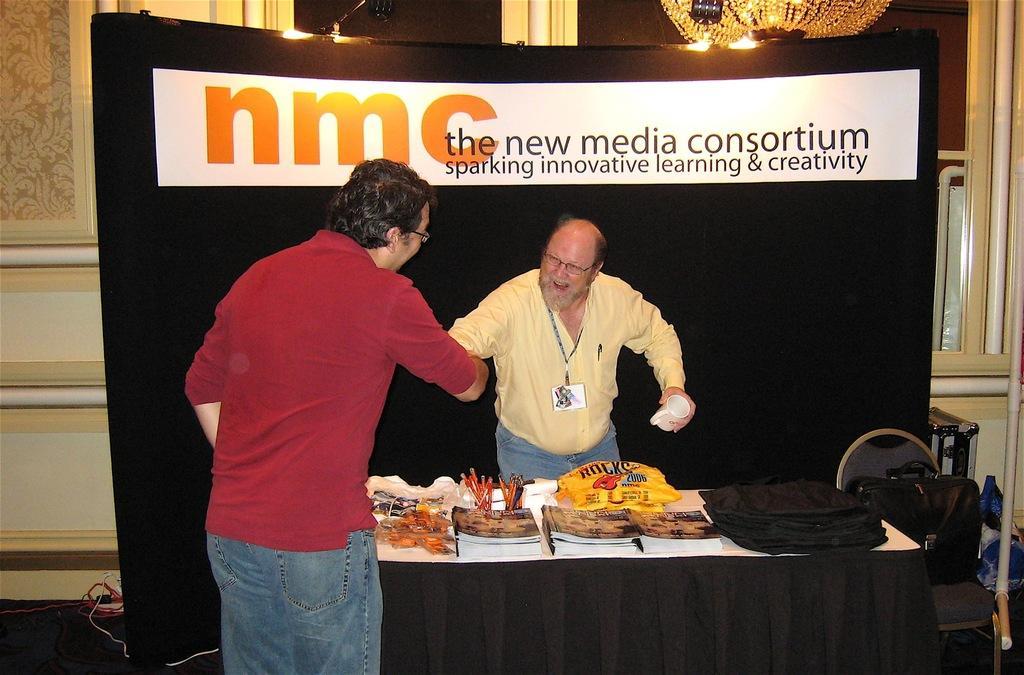Describe this image in one or two sentences. In this image there are two persons who are shaking their hands and in between them there are books,bags,pens which are on the table and at the background of the image there is a black color sheet. 